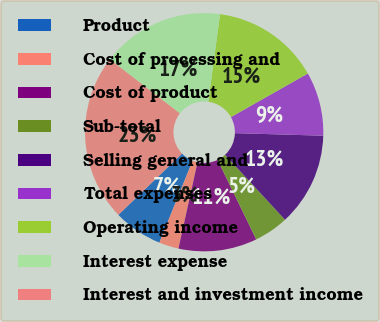Convert chart. <chart><loc_0><loc_0><loc_500><loc_500><pie_chart><fcel>Product<fcel>Cost of processing and<fcel>Cost of product<fcel>Sub-total<fcel>Selling general and<fcel>Total expenses<fcel>Operating income<fcel>Interest expense<fcel>Interest and investment income<nl><fcel>6.67%<fcel>2.67%<fcel>10.67%<fcel>4.67%<fcel>12.67%<fcel>8.67%<fcel>14.67%<fcel>16.67%<fcel>22.67%<nl></chart> 